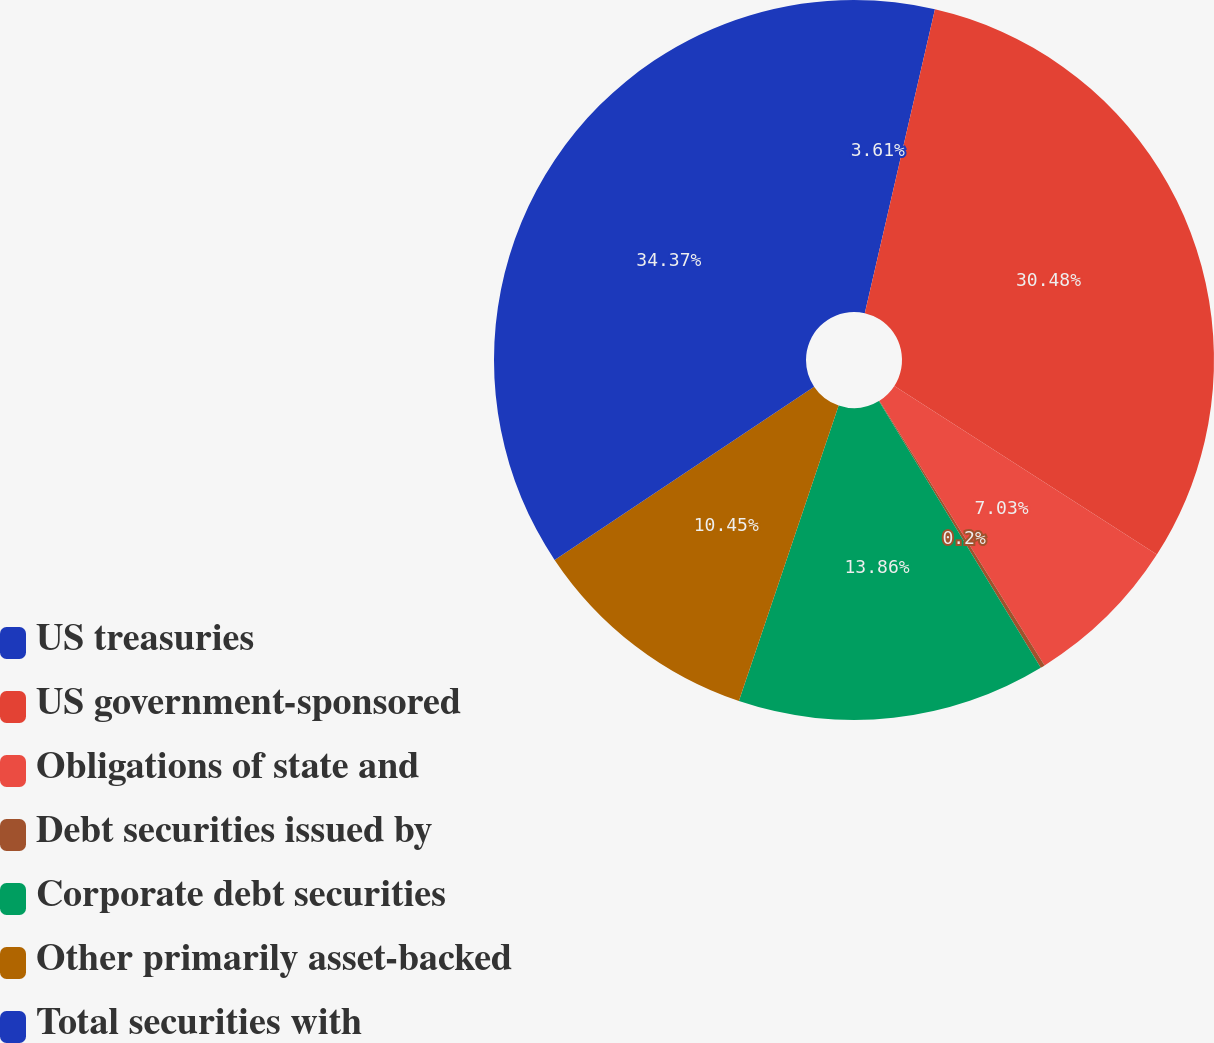<chart> <loc_0><loc_0><loc_500><loc_500><pie_chart><fcel>US treasuries<fcel>US government-sponsored<fcel>Obligations of state and<fcel>Debt securities issued by<fcel>Corporate debt securities<fcel>Other primarily asset-backed<fcel>Total securities with<nl><fcel>3.61%<fcel>30.48%<fcel>7.03%<fcel>0.2%<fcel>13.86%<fcel>10.45%<fcel>34.37%<nl></chart> 